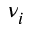Convert formula to latex. <formula><loc_0><loc_0><loc_500><loc_500>\nu _ { i }</formula> 